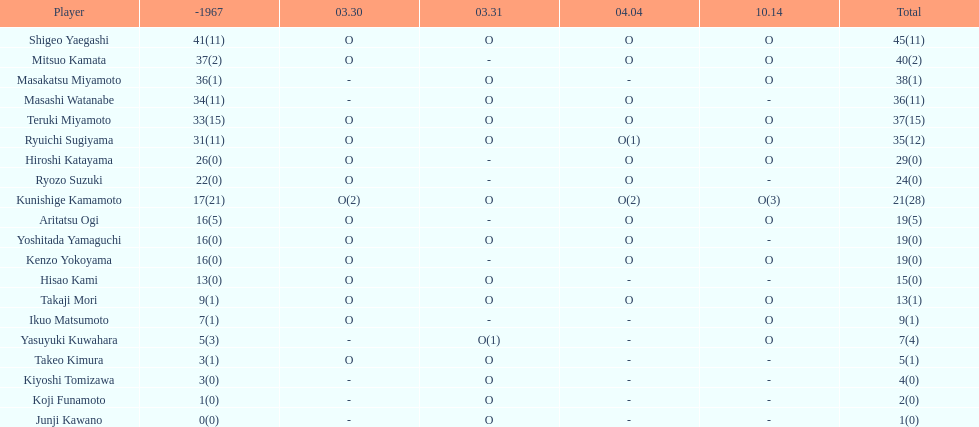Who had more points takaji mori or junji kawano? Takaji Mori. 